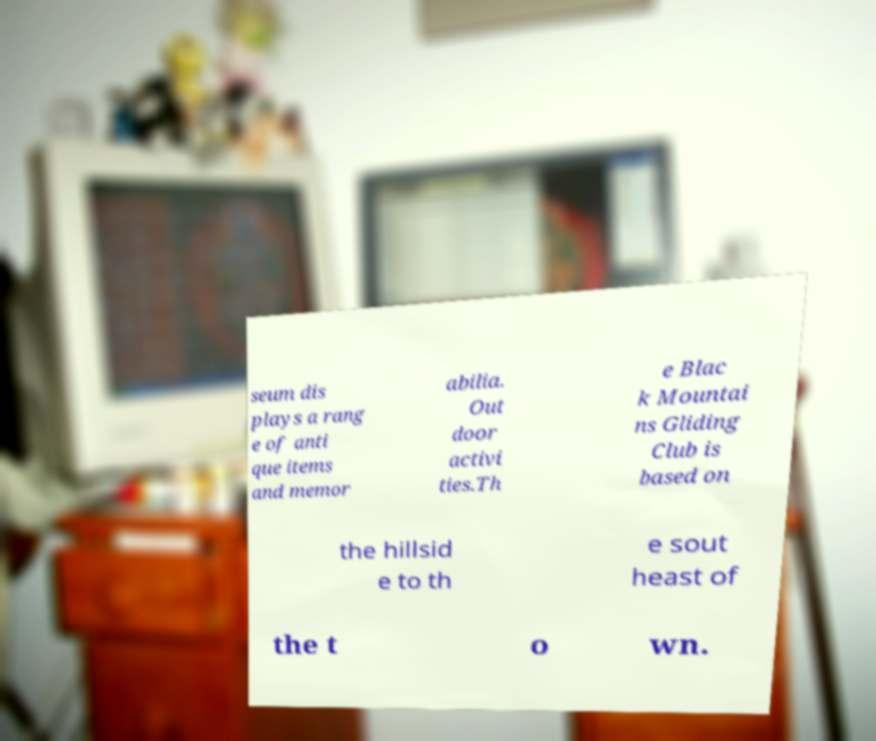For documentation purposes, I need the text within this image transcribed. Could you provide that? seum dis plays a rang e of anti que items and memor abilia. Out door activi ties.Th e Blac k Mountai ns Gliding Club is based on the hillsid e to th e sout heast of the t o wn. 